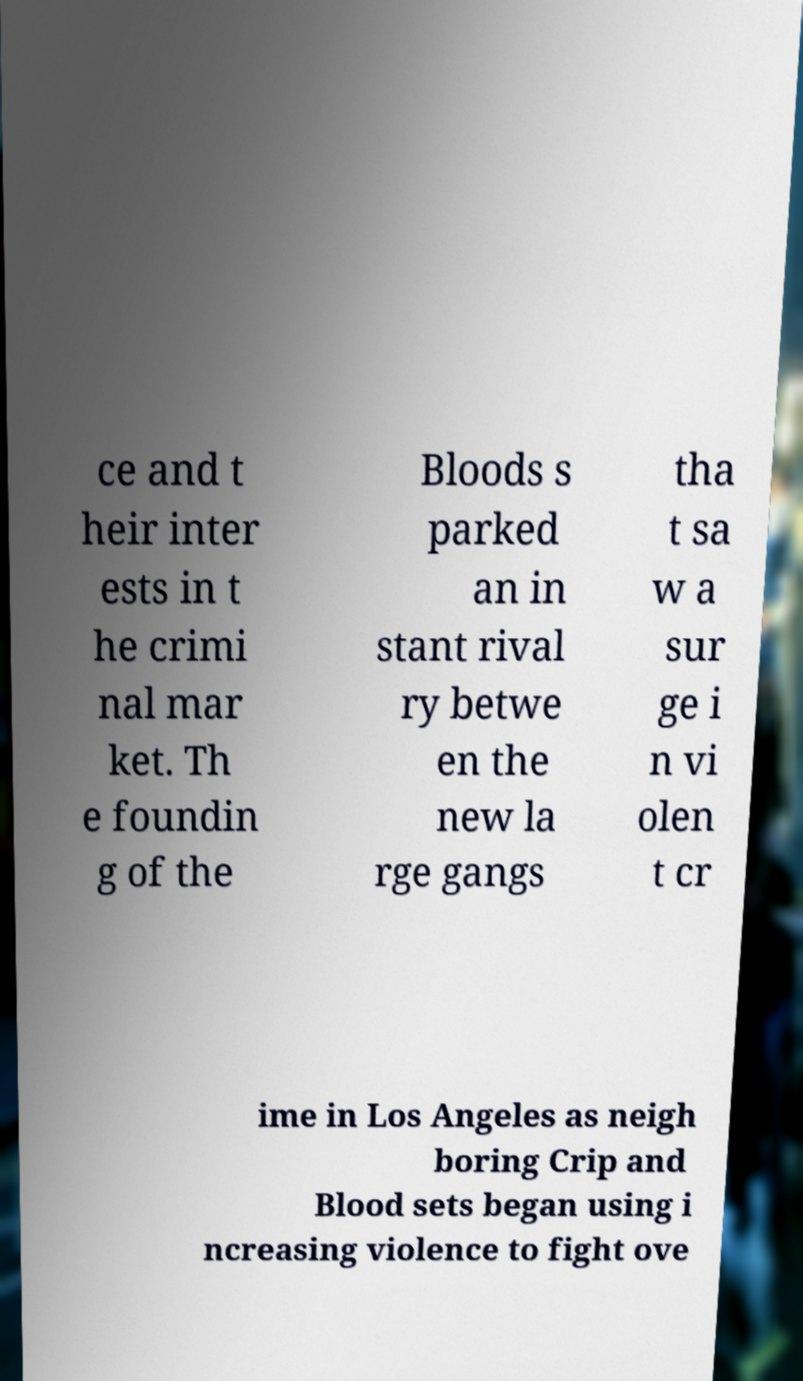Can you read and provide the text displayed in the image?This photo seems to have some interesting text. Can you extract and type it out for me? ce and t heir inter ests in t he crimi nal mar ket. Th e foundin g of the Bloods s parked an in stant rival ry betwe en the new la rge gangs tha t sa w a sur ge i n vi olen t cr ime in Los Angeles as neigh boring Crip and Blood sets began using i ncreasing violence to fight ove 